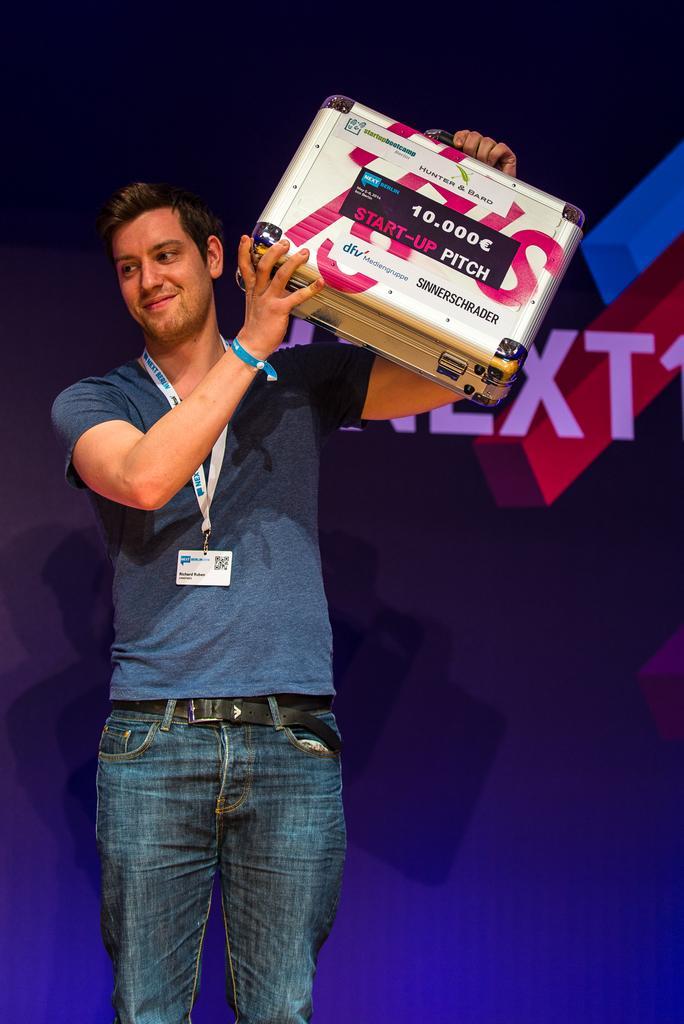Please provide a concise description of this image. In this image there is a person standing and holding a briefcase , and at the background there is a board. 